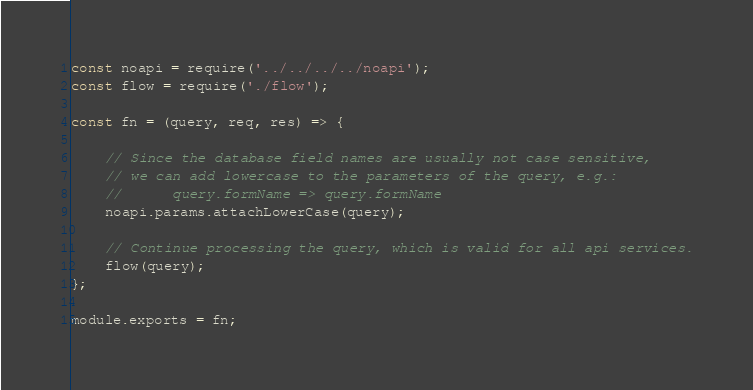<code> <loc_0><loc_0><loc_500><loc_500><_JavaScript_>
const noapi = require('../../../../noapi');
const flow = require('./flow');

const fn = (query, req, res) => {

	// Since the database field names are usually not case sensitive,
	// we can add lowercase to the parameters of the query, e.g.:
	//		query.formName => query.formName
	noapi.params.attachLowerCase(query);

	// Continue processing the query, which is valid for all api services.
	flow(query);
};

module.exports = fn;
</code> 